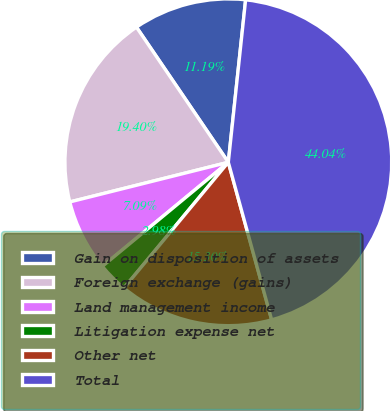Convert chart. <chart><loc_0><loc_0><loc_500><loc_500><pie_chart><fcel>Gain on disposition of assets<fcel>Foreign exchange (gains)<fcel>Land management income<fcel>Litigation expense net<fcel>Other net<fcel>Total<nl><fcel>11.19%<fcel>19.4%<fcel>7.09%<fcel>2.98%<fcel>15.3%<fcel>44.04%<nl></chart> 